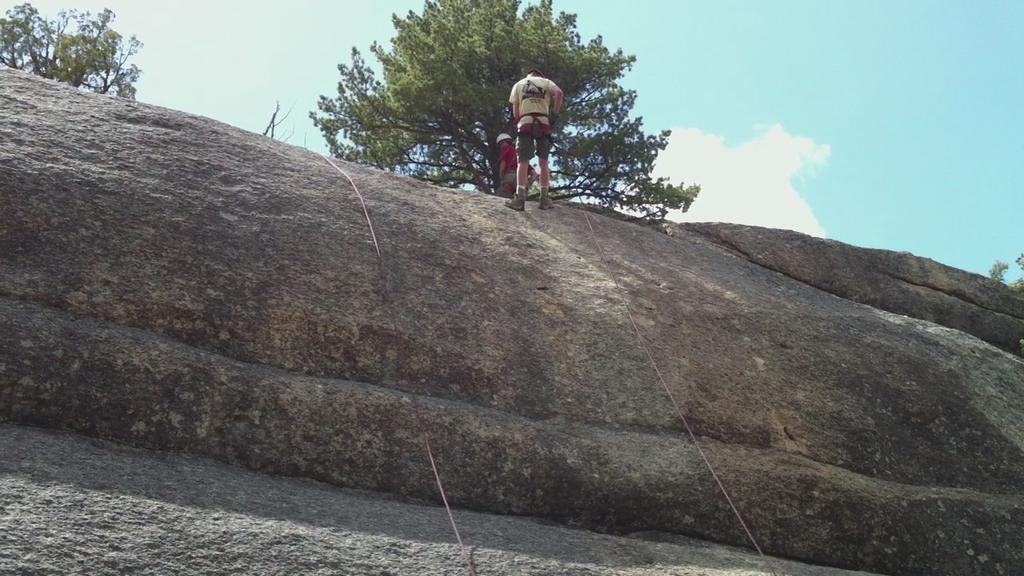How many people are in the image? There are two persons in the image. Where are the persons located? The persons are on a rock in the image. What else can be seen in the image besides the persons? There are ropes and trees visible in the image. What is visible in the background of the image? The sky with clouds is visible in the background of the image. What type of tomatoes can be seen growing on the trees in the image? There are no tomatoes or trees growing tomatoes present in the image. Can you recite a verse that is relevant to the scene in the image? There is no verse provided or implied in the image, so it cannot be recited. 